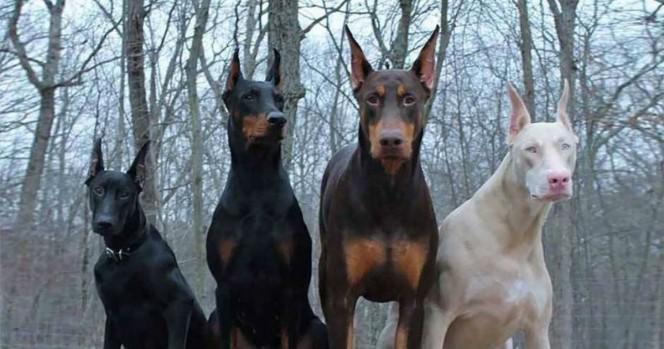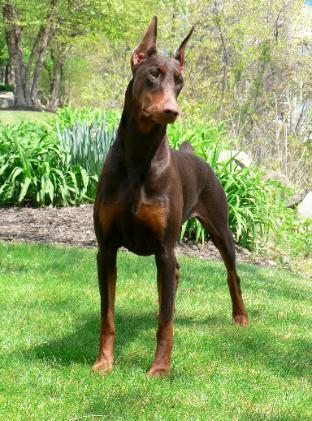The first image is the image on the left, the second image is the image on the right. Evaluate the accuracy of this statement regarding the images: "At least one dog is laying down.". Is it true? Answer yes or no. No. The first image is the image on the left, the second image is the image on the right. For the images shown, is this caption "Three or more dogs are visible." true? Answer yes or no. Yes. 